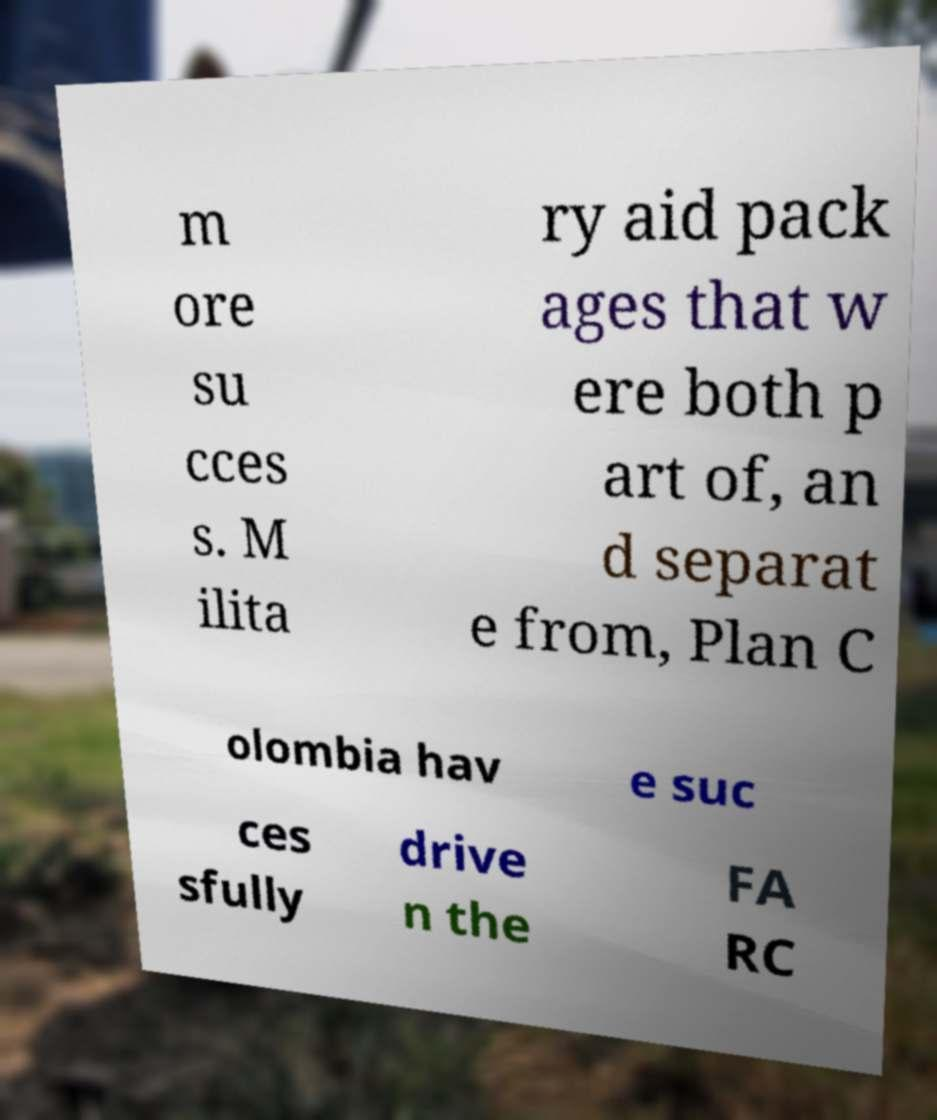What messages or text are displayed in this image? I need them in a readable, typed format. m ore su cces s. M ilita ry aid pack ages that w ere both p art of, an d separat e from, Plan C olombia hav e suc ces sfully drive n the FA RC 